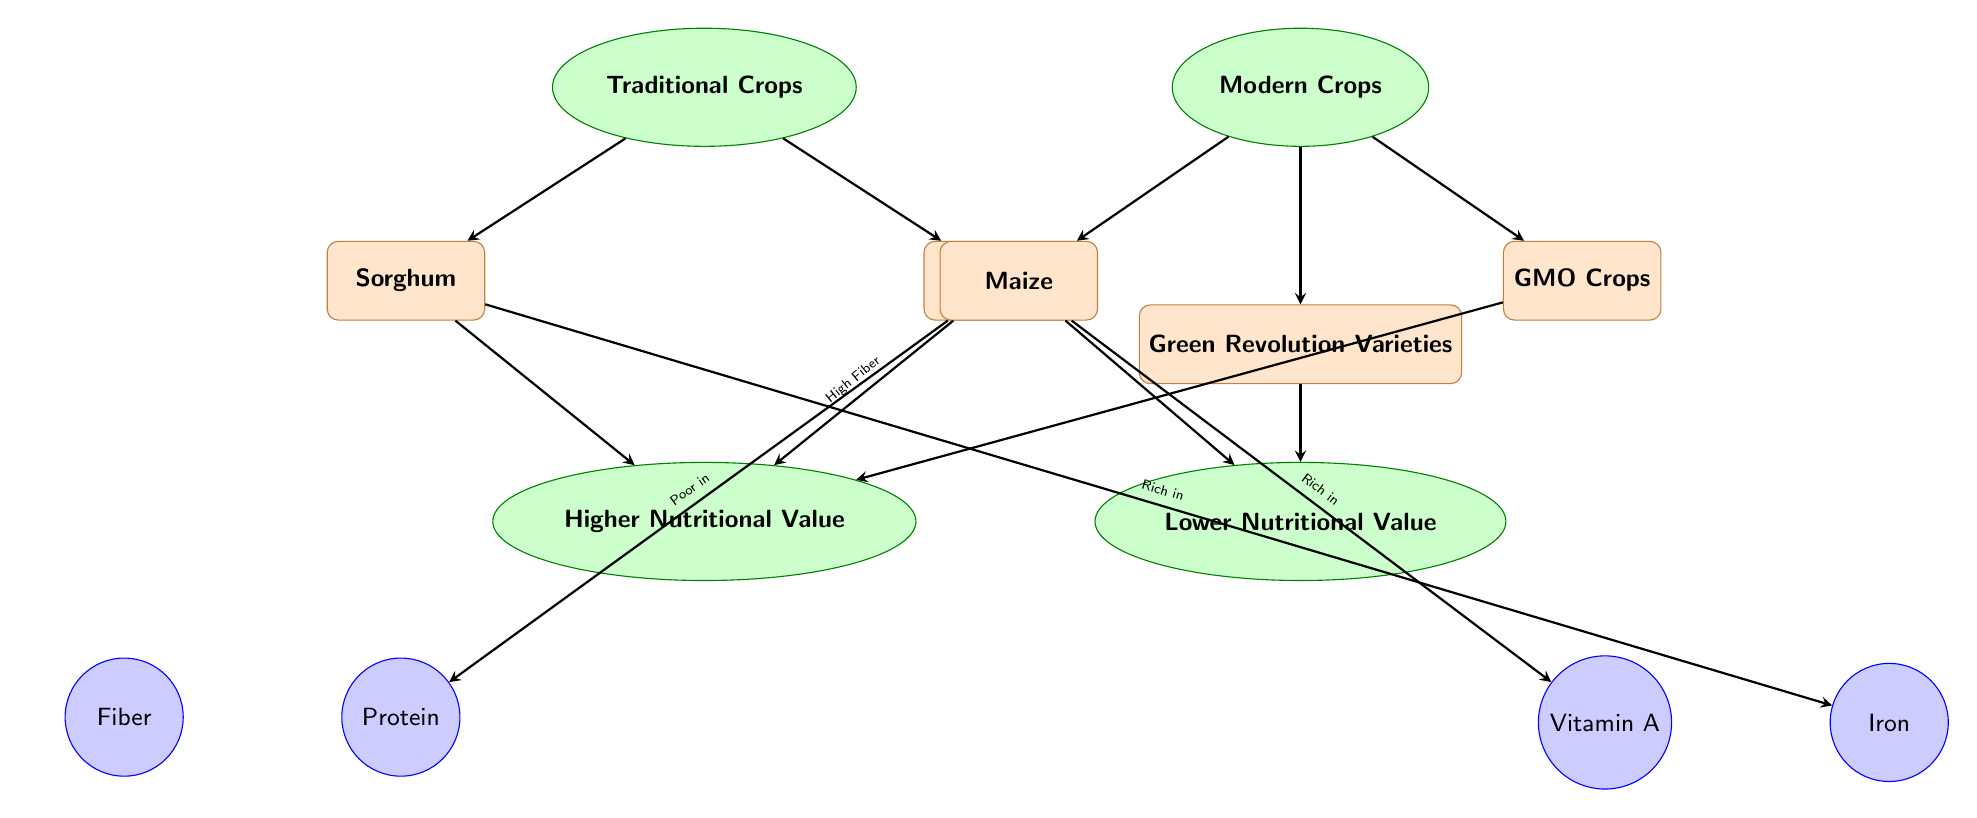What traditional crop is rich in iron? The diagram shows that Sorghum is connected to the nutrient Iron with an arrow labeled "Rich in." This indicates Sorghum's high iron content compared to other crops in the traditional category.
Answer: Sorghum Which crop in the modern category is associated with lower nutritional value? The diagram indicates that both Maize and Green Revolution Varieties lead to the node labeled "Lower Nutritional Value." This node is under the Modern Crops category, meaning at least one modern crop has lower nutritional properties.
Answer: Maize How many traditional crops are displayed in the diagram? The traditional crops displayed include Sorghum and Cassava, which makes a total of two traditional crops shown within the traditional category node.
Answer: 2 Which nutrient is shown to be high in Cassava? The diagram points an arrow from Cassava to the category labeled "Higher Nutritional Value," with a notation "High Fiber," indicating it is rich in fiber.
Answer: Fiber What modern crop has an arrow leading to a higher nutritional value? The diagram connects GMO Crops to the node labeled "Higher Nutritional Value," signifying that this crop provides higher nutritional benefits compared to others.
Answer: GMO Crops What is the relationship between traditional crops and nutritional value? The diagram illustrates that traditional crops such as Sorghum and Cassava lead to the "Higher Nutritional Value" category, showing that their contribution is significantly beneficial.
Answer: Higher Nutritional Value Which nutrient is associated with maize? The diagram connects Maize with Vitamin A through an arrow labeled "Rich in," indicating its contribution to higher levels of vitamin intake.
Answer: Vitamin A Which traditional crop is poor in protein? The diagram highlights that Cassava leads, with a connection indicating "Poor in Protein," showing its low protein content in the traditional crop category.
Answer: Cassava 